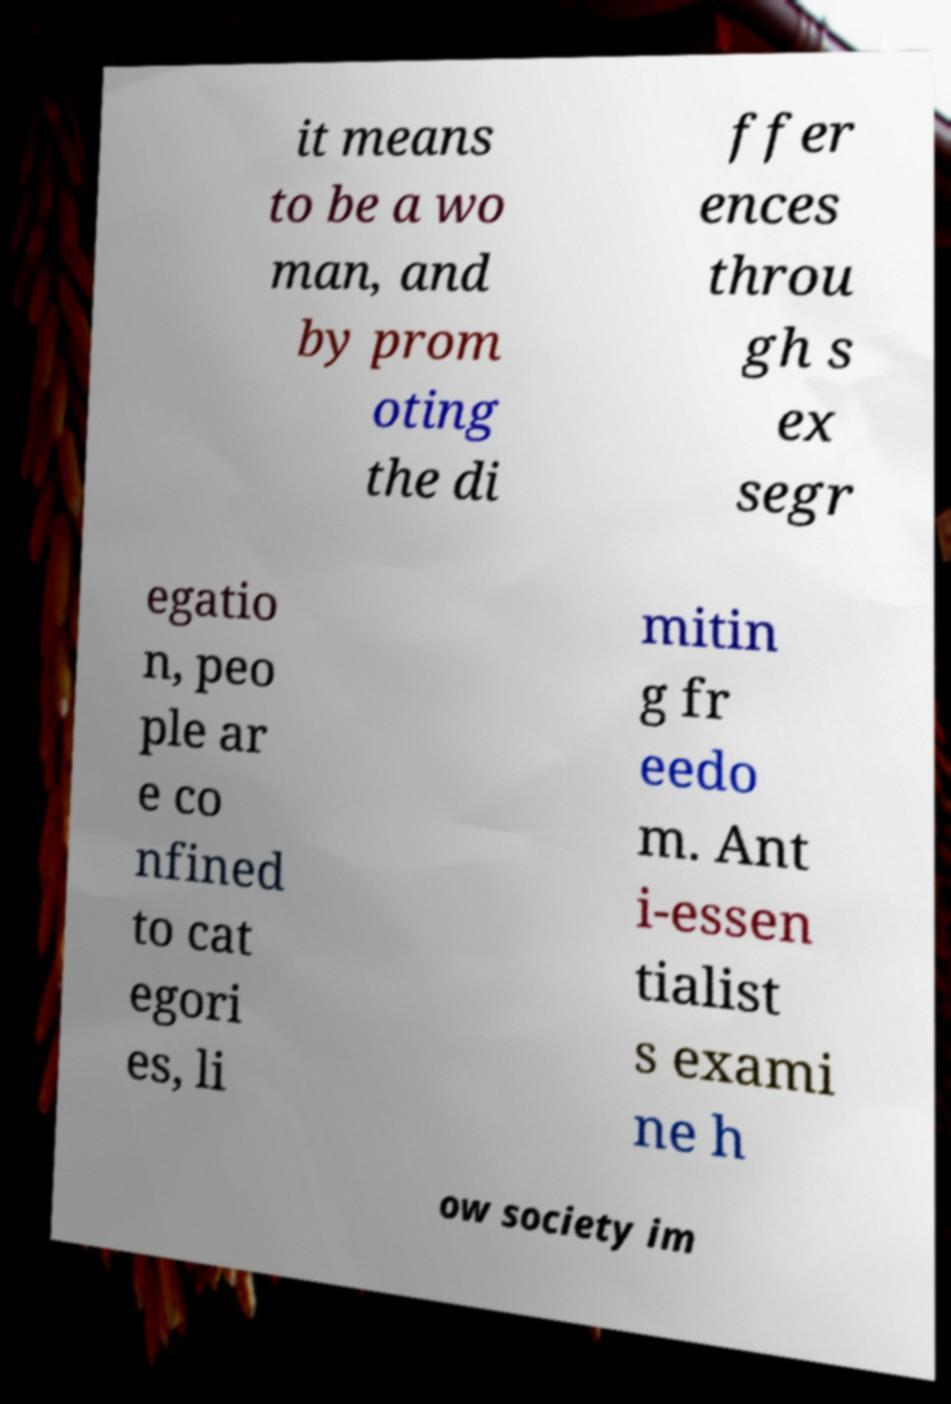Please read and relay the text visible in this image. What does it say? it means to be a wo man, and by prom oting the di ffer ences throu gh s ex segr egatio n, peo ple ar e co nfined to cat egori es, li mitin g fr eedo m. Ant i-essen tialist s exami ne h ow society im 